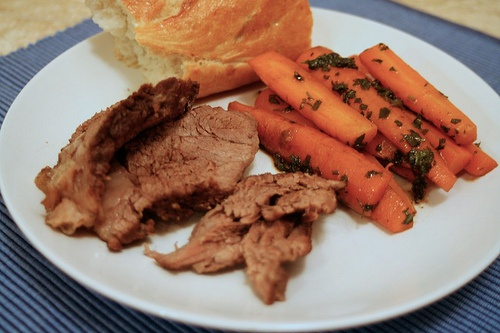Describe the objects in this image and their specific colors. I can see carrot in tan, red, brown, and maroon tones, carrot in tan, red, brown, and maroon tones, carrot in tan, brown, red, maroon, and black tones, carrot in tan, red, salmon, orange, and brown tones, and carrot in tan, brown, and maroon tones in this image. 